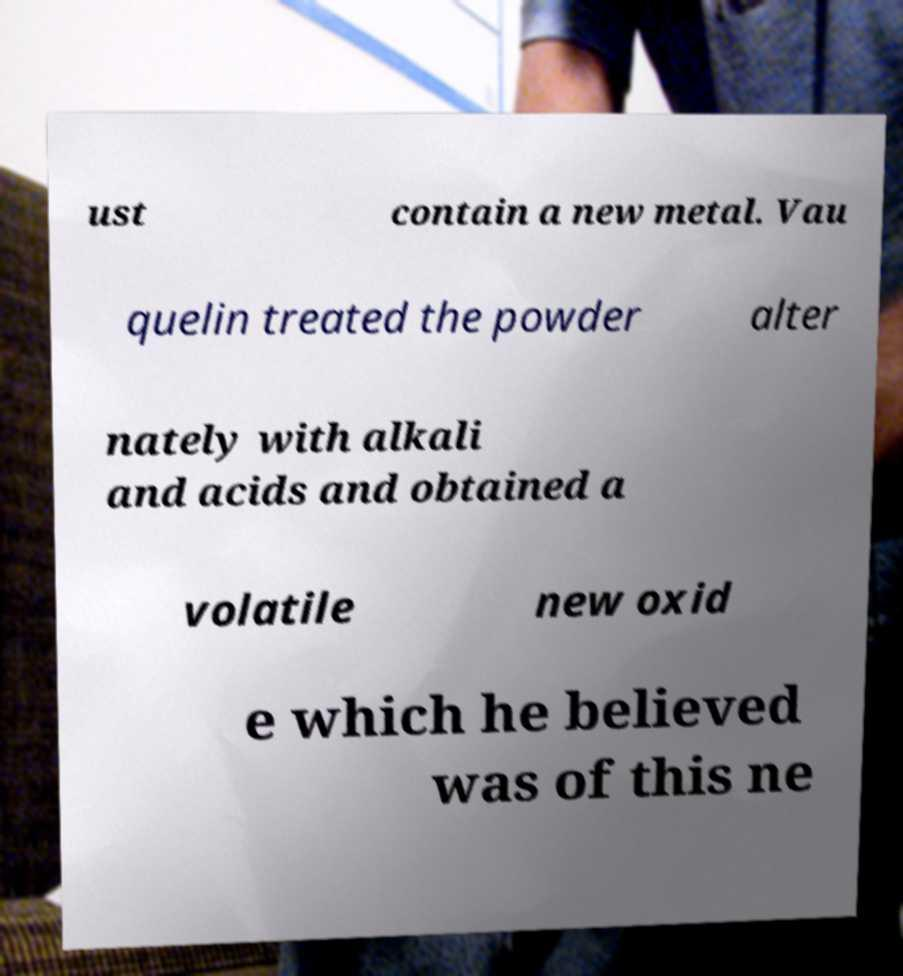Please identify and transcribe the text found in this image. ust contain a new metal. Vau quelin treated the powder alter nately with alkali and acids and obtained a volatile new oxid e which he believed was of this ne 